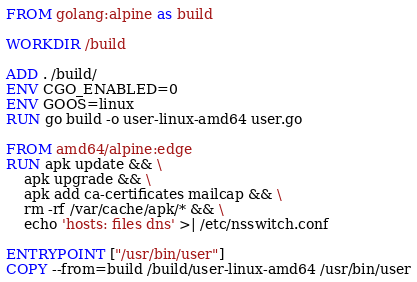<code> <loc_0><loc_0><loc_500><loc_500><_Dockerfile_>FROM golang:alpine as build

WORKDIR /build

ADD . /build/
ENV CGO_ENABLED=0 
ENV GOOS=linux
RUN go build -o user-linux-amd64 user.go

FROM amd64/alpine:edge
RUN apk update && \
	apk upgrade && \
	apk add ca-certificates mailcap && \
	rm -rf /var/cache/apk/* && \
	echo 'hosts: files dns' >| /etc/nsswitch.conf

ENTRYPOINT ["/usr/bin/user"]
COPY --from=build /build/user-linux-amd64 /usr/bin/user</code> 